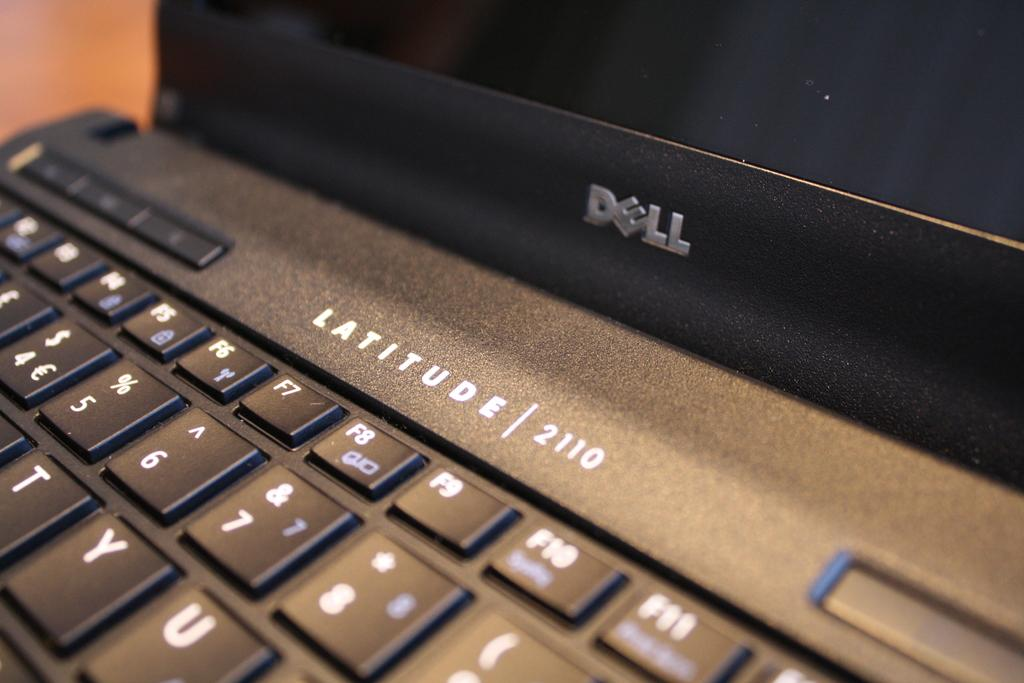What electronic device is visible in the image? There is a laptop in the image. What colors are present on the laptop? The laptop is black and grey in color. What can be found on the laptop's keyboard? The laptop's keyboard has numbers and alphabets. Where can you find the library of apparel in the image? There is no library or apparel present in the image; it only features a laptop. 